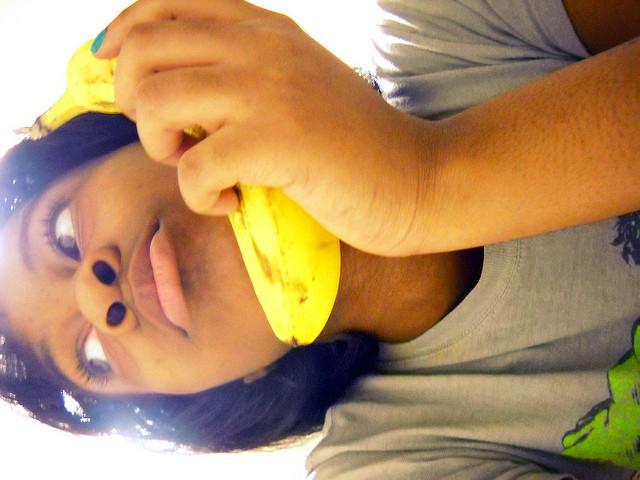What color is her nail polish?
Concise answer only. Blue. What are on her fingers?
Keep it brief. Banana. Is she smiling at the photographer?
Concise answer only. No. Is the banana ripe enough to eat?
Give a very brief answer. Yes. What is she holding?
Write a very short answer. Banana. 